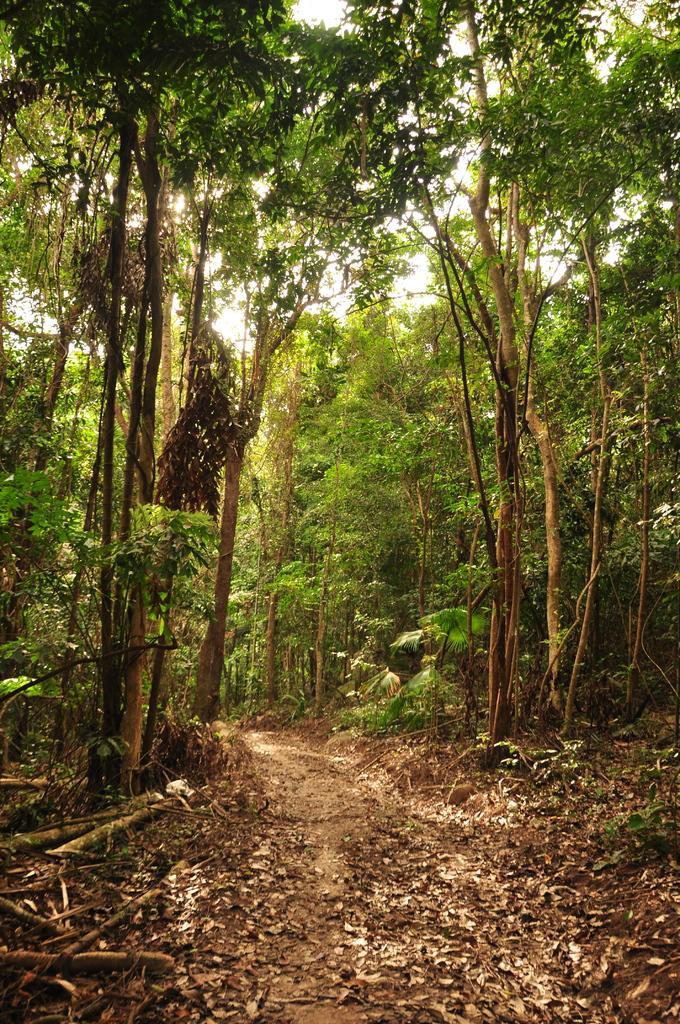Please provide a concise description of this image. In this image we can see some trees, plants, leaves on the ground, sticks, also we can see the sky. 